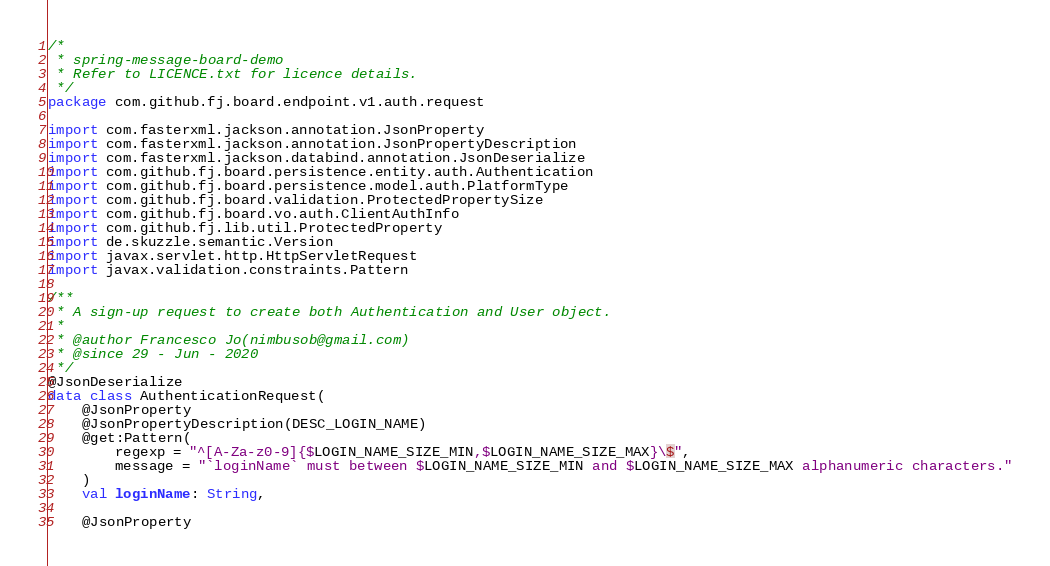Convert code to text. <code><loc_0><loc_0><loc_500><loc_500><_Kotlin_>/*
 * spring-message-board-demo
 * Refer to LICENCE.txt for licence details.
 */
package com.github.fj.board.endpoint.v1.auth.request

import com.fasterxml.jackson.annotation.JsonProperty
import com.fasterxml.jackson.annotation.JsonPropertyDescription
import com.fasterxml.jackson.databind.annotation.JsonDeserialize
import com.github.fj.board.persistence.entity.auth.Authentication
import com.github.fj.board.persistence.model.auth.PlatformType
import com.github.fj.board.validation.ProtectedPropertySize
import com.github.fj.board.vo.auth.ClientAuthInfo
import com.github.fj.lib.util.ProtectedProperty
import de.skuzzle.semantic.Version
import javax.servlet.http.HttpServletRequest
import javax.validation.constraints.Pattern

/**
 * A sign-up request to create both Authentication and User object.
 *
 * @author Francesco Jo(nimbusob@gmail.com)
 * @since 29 - Jun - 2020
 */
@JsonDeserialize
data class AuthenticationRequest(
    @JsonProperty
    @JsonPropertyDescription(DESC_LOGIN_NAME)
    @get:Pattern(
        regexp = "^[A-Za-z0-9]{$LOGIN_NAME_SIZE_MIN,$LOGIN_NAME_SIZE_MAX}\$",
        message = "`loginName` must between $LOGIN_NAME_SIZE_MIN and $LOGIN_NAME_SIZE_MAX alphanumeric characters."
    )
    val loginName: String,

    @JsonProperty</code> 